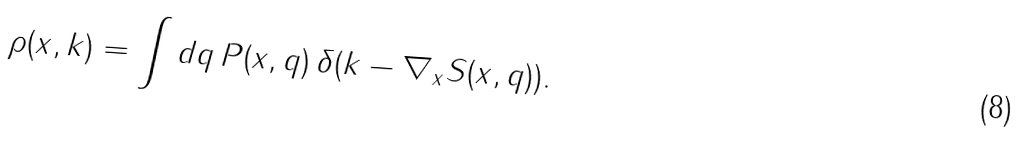<formula> <loc_0><loc_0><loc_500><loc_500>\rho ( x , k ) = \int d q \, P ( x , q ) \, \delta ( k - \nabla _ { x } S ( x , q ) ) .</formula> 